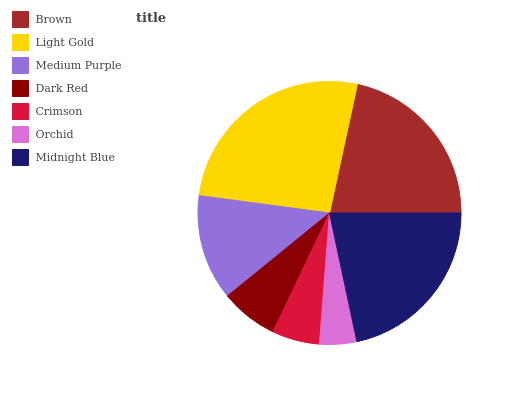Is Orchid the minimum?
Answer yes or no. Yes. Is Light Gold the maximum?
Answer yes or no. Yes. Is Medium Purple the minimum?
Answer yes or no. No. Is Medium Purple the maximum?
Answer yes or no. No. Is Light Gold greater than Medium Purple?
Answer yes or no. Yes. Is Medium Purple less than Light Gold?
Answer yes or no. Yes. Is Medium Purple greater than Light Gold?
Answer yes or no. No. Is Light Gold less than Medium Purple?
Answer yes or no. No. Is Medium Purple the high median?
Answer yes or no. Yes. Is Medium Purple the low median?
Answer yes or no. Yes. Is Dark Red the high median?
Answer yes or no. No. Is Dark Red the low median?
Answer yes or no. No. 